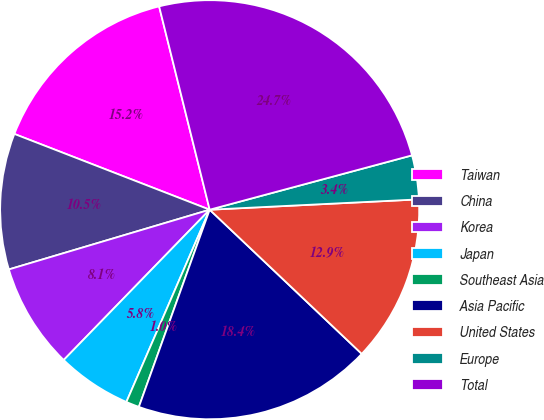Convert chart to OTSL. <chart><loc_0><loc_0><loc_500><loc_500><pie_chart><fcel>Taiwan<fcel>China<fcel>Korea<fcel>Japan<fcel>Southeast Asia<fcel>Asia Pacific<fcel>United States<fcel>Europe<fcel>Total<nl><fcel>15.23%<fcel>10.49%<fcel>8.13%<fcel>5.76%<fcel>1.02%<fcel>18.41%<fcel>12.86%<fcel>3.39%<fcel>24.7%<nl></chart> 